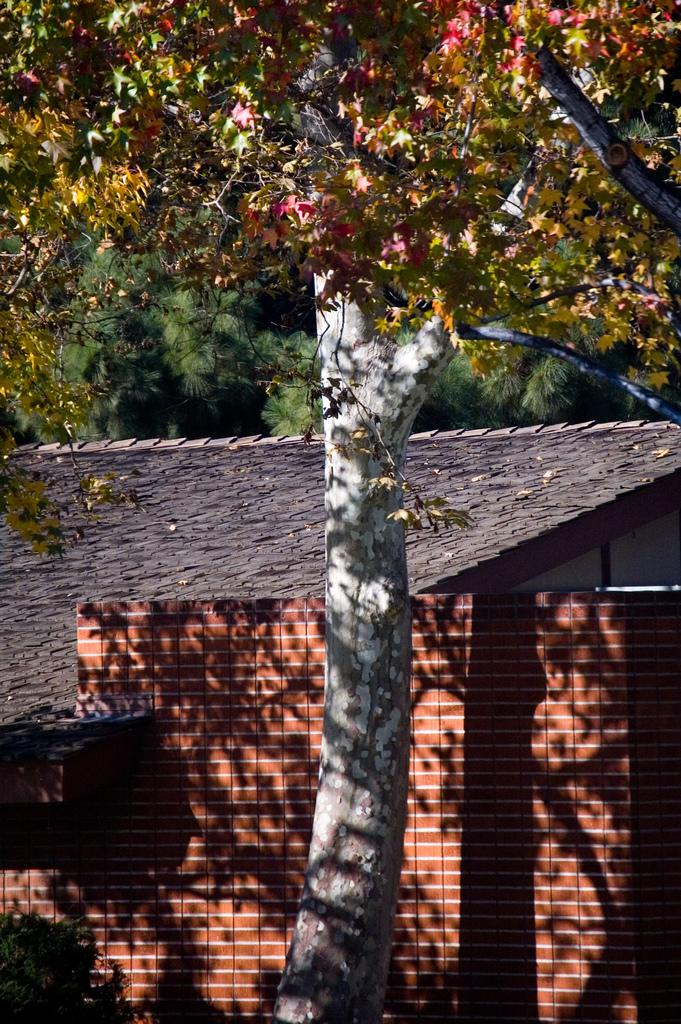What is the main structure in the center of the image? There is a shed in the center of the image. What can be seen in the background of the image? There are trees in the background of the image. What type of chalk is being used to draw on the shed in the image? There is no chalk or drawing present on the shed in the image. What substance can be seen on the moon in the image? There is no moon present in the image; it only features a shed and trees in the background. 